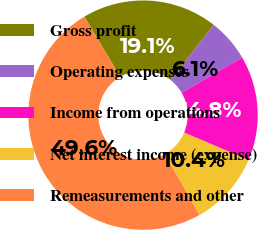Convert chart to OTSL. <chart><loc_0><loc_0><loc_500><loc_500><pie_chart><fcel>Gross profit<fcel>Operating expenses<fcel>Income from operations<fcel>Net interest income (expense)<fcel>Remeasurements and other<nl><fcel>19.13%<fcel>6.05%<fcel>14.77%<fcel>10.41%<fcel>49.64%<nl></chart> 